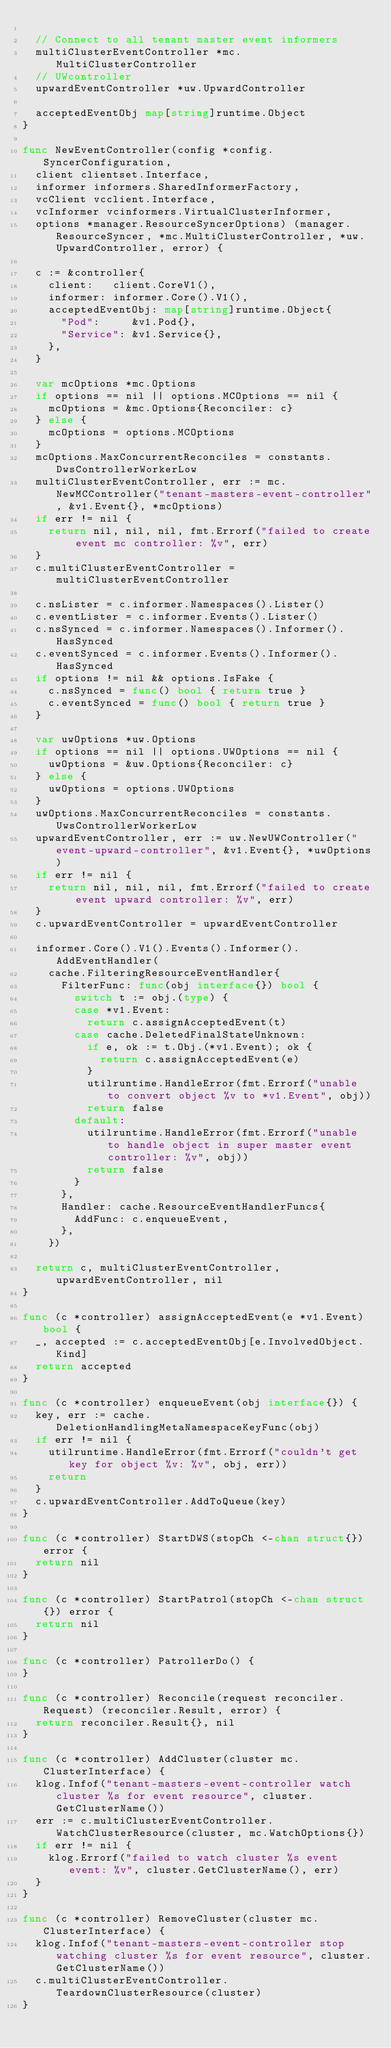Convert code to text. <code><loc_0><loc_0><loc_500><loc_500><_Go_>
	// Connect to all tenant master event informers
	multiClusterEventController *mc.MultiClusterController
	// UWcontroller
	upwardEventController *uw.UpwardController

	acceptedEventObj map[string]runtime.Object
}

func NewEventController(config *config.SyncerConfiguration,
	client clientset.Interface,
	informer informers.SharedInformerFactory,
	vcClient vcclient.Interface,
	vcInformer vcinformers.VirtualClusterInformer,
	options *manager.ResourceSyncerOptions) (manager.ResourceSyncer, *mc.MultiClusterController, *uw.UpwardController, error) {

	c := &controller{
		client:   client.CoreV1(),
		informer: informer.Core().V1(),
		acceptedEventObj: map[string]runtime.Object{
			"Pod":     &v1.Pod{},
			"Service": &v1.Service{},
		},
	}

	var mcOptions *mc.Options
	if options == nil || options.MCOptions == nil {
		mcOptions = &mc.Options{Reconciler: c}
	} else {
		mcOptions = options.MCOptions
	}
	mcOptions.MaxConcurrentReconciles = constants.DwsControllerWorkerLow
	multiClusterEventController, err := mc.NewMCController("tenant-masters-event-controller", &v1.Event{}, *mcOptions)
	if err != nil {
		return nil, nil, nil, fmt.Errorf("failed to create event mc controller: %v", err)
	}
	c.multiClusterEventController = multiClusterEventController

	c.nsLister = c.informer.Namespaces().Lister()
	c.eventLister = c.informer.Events().Lister()
	c.nsSynced = c.informer.Namespaces().Informer().HasSynced
	c.eventSynced = c.informer.Events().Informer().HasSynced
	if options != nil && options.IsFake {
		c.nsSynced = func() bool { return true }
		c.eventSynced = func() bool { return true }
	}

	var uwOptions *uw.Options
	if options == nil || options.UWOptions == nil {
		uwOptions = &uw.Options{Reconciler: c}
	} else {
		uwOptions = options.UWOptions
	}
	uwOptions.MaxConcurrentReconciles = constants.UwsControllerWorkerLow
	upwardEventController, err := uw.NewUWController("event-upward-controller", &v1.Event{}, *uwOptions)
	if err != nil {
		return nil, nil, nil, fmt.Errorf("failed to create event upward controller: %v", err)
	}
	c.upwardEventController = upwardEventController

	informer.Core().V1().Events().Informer().AddEventHandler(
		cache.FilteringResourceEventHandler{
			FilterFunc: func(obj interface{}) bool {
				switch t := obj.(type) {
				case *v1.Event:
					return c.assignAcceptedEvent(t)
				case cache.DeletedFinalStateUnknown:
					if e, ok := t.Obj.(*v1.Event); ok {
						return c.assignAcceptedEvent(e)
					}
					utilruntime.HandleError(fmt.Errorf("unable to convert object %v to *v1.Event", obj))
					return false
				default:
					utilruntime.HandleError(fmt.Errorf("unable to handle object in super master event controller: %v", obj))
					return false
				}
			},
			Handler: cache.ResourceEventHandlerFuncs{
				AddFunc: c.enqueueEvent,
			},
		})

	return c, multiClusterEventController, upwardEventController, nil
}

func (c *controller) assignAcceptedEvent(e *v1.Event) bool {
	_, accepted := c.acceptedEventObj[e.InvolvedObject.Kind]
	return accepted
}

func (c *controller) enqueueEvent(obj interface{}) {
	key, err := cache.DeletionHandlingMetaNamespaceKeyFunc(obj)
	if err != nil {
		utilruntime.HandleError(fmt.Errorf("couldn't get key for object %v: %v", obj, err))
		return
	}
	c.upwardEventController.AddToQueue(key)
}

func (c *controller) StartDWS(stopCh <-chan struct{}) error {
	return nil
}

func (c *controller) StartPatrol(stopCh <-chan struct{}) error {
	return nil
}

func (c *controller) PatrollerDo() {
}

func (c *controller) Reconcile(request reconciler.Request) (reconciler.Result, error) {
	return reconciler.Result{}, nil
}

func (c *controller) AddCluster(cluster mc.ClusterInterface) {
	klog.Infof("tenant-masters-event-controller watch cluster %s for event resource", cluster.GetClusterName())
	err := c.multiClusterEventController.WatchClusterResource(cluster, mc.WatchOptions{})
	if err != nil {
		klog.Errorf("failed to watch cluster %s event event: %v", cluster.GetClusterName(), err)
	}
}

func (c *controller) RemoveCluster(cluster mc.ClusterInterface) {
	klog.Infof("tenant-masters-event-controller stop watching cluster %s for event resource", cluster.GetClusterName())
	c.multiClusterEventController.TeardownClusterResource(cluster)
}
</code> 